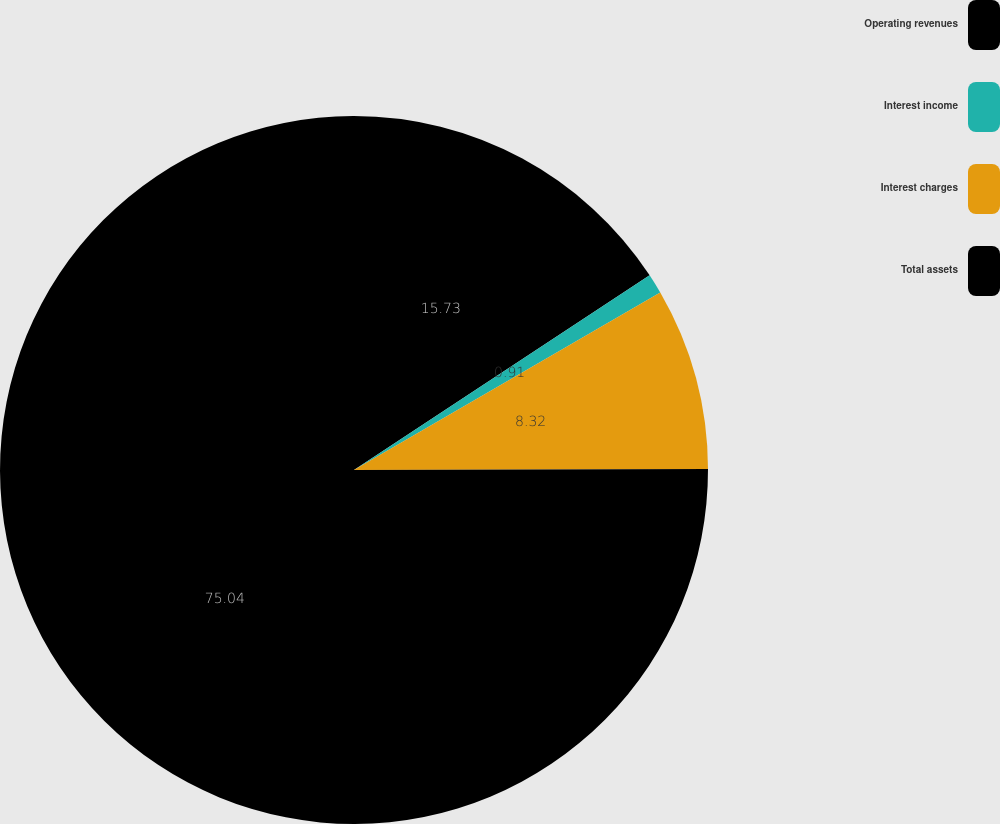Convert chart. <chart><loc_0><loc_0><loc_500><loc_500><pie_chart><fcel>Operating revenues<fcel>Interest income<fcel>Interest charges<fcel>Total assets<nl><fcel>15.73%<fcel>0.91%<fcel>8.32%<fcel>75.04%<nl></chart> 